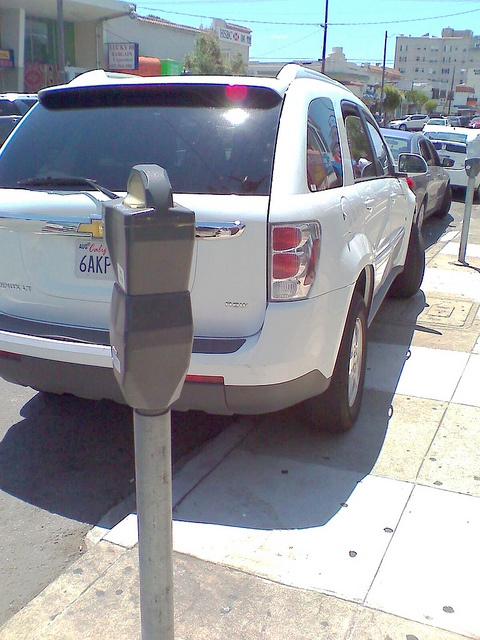Describe the objects in this image and their specific colors. I can see car in gray, darkgray, and white tones, parking meter in gray, darkgray, and white tones, car in gray, darkgray, and black tones, car in gray, darkgray, white, and lightblue tones, and car in gray, blue, and white tones in this image. 